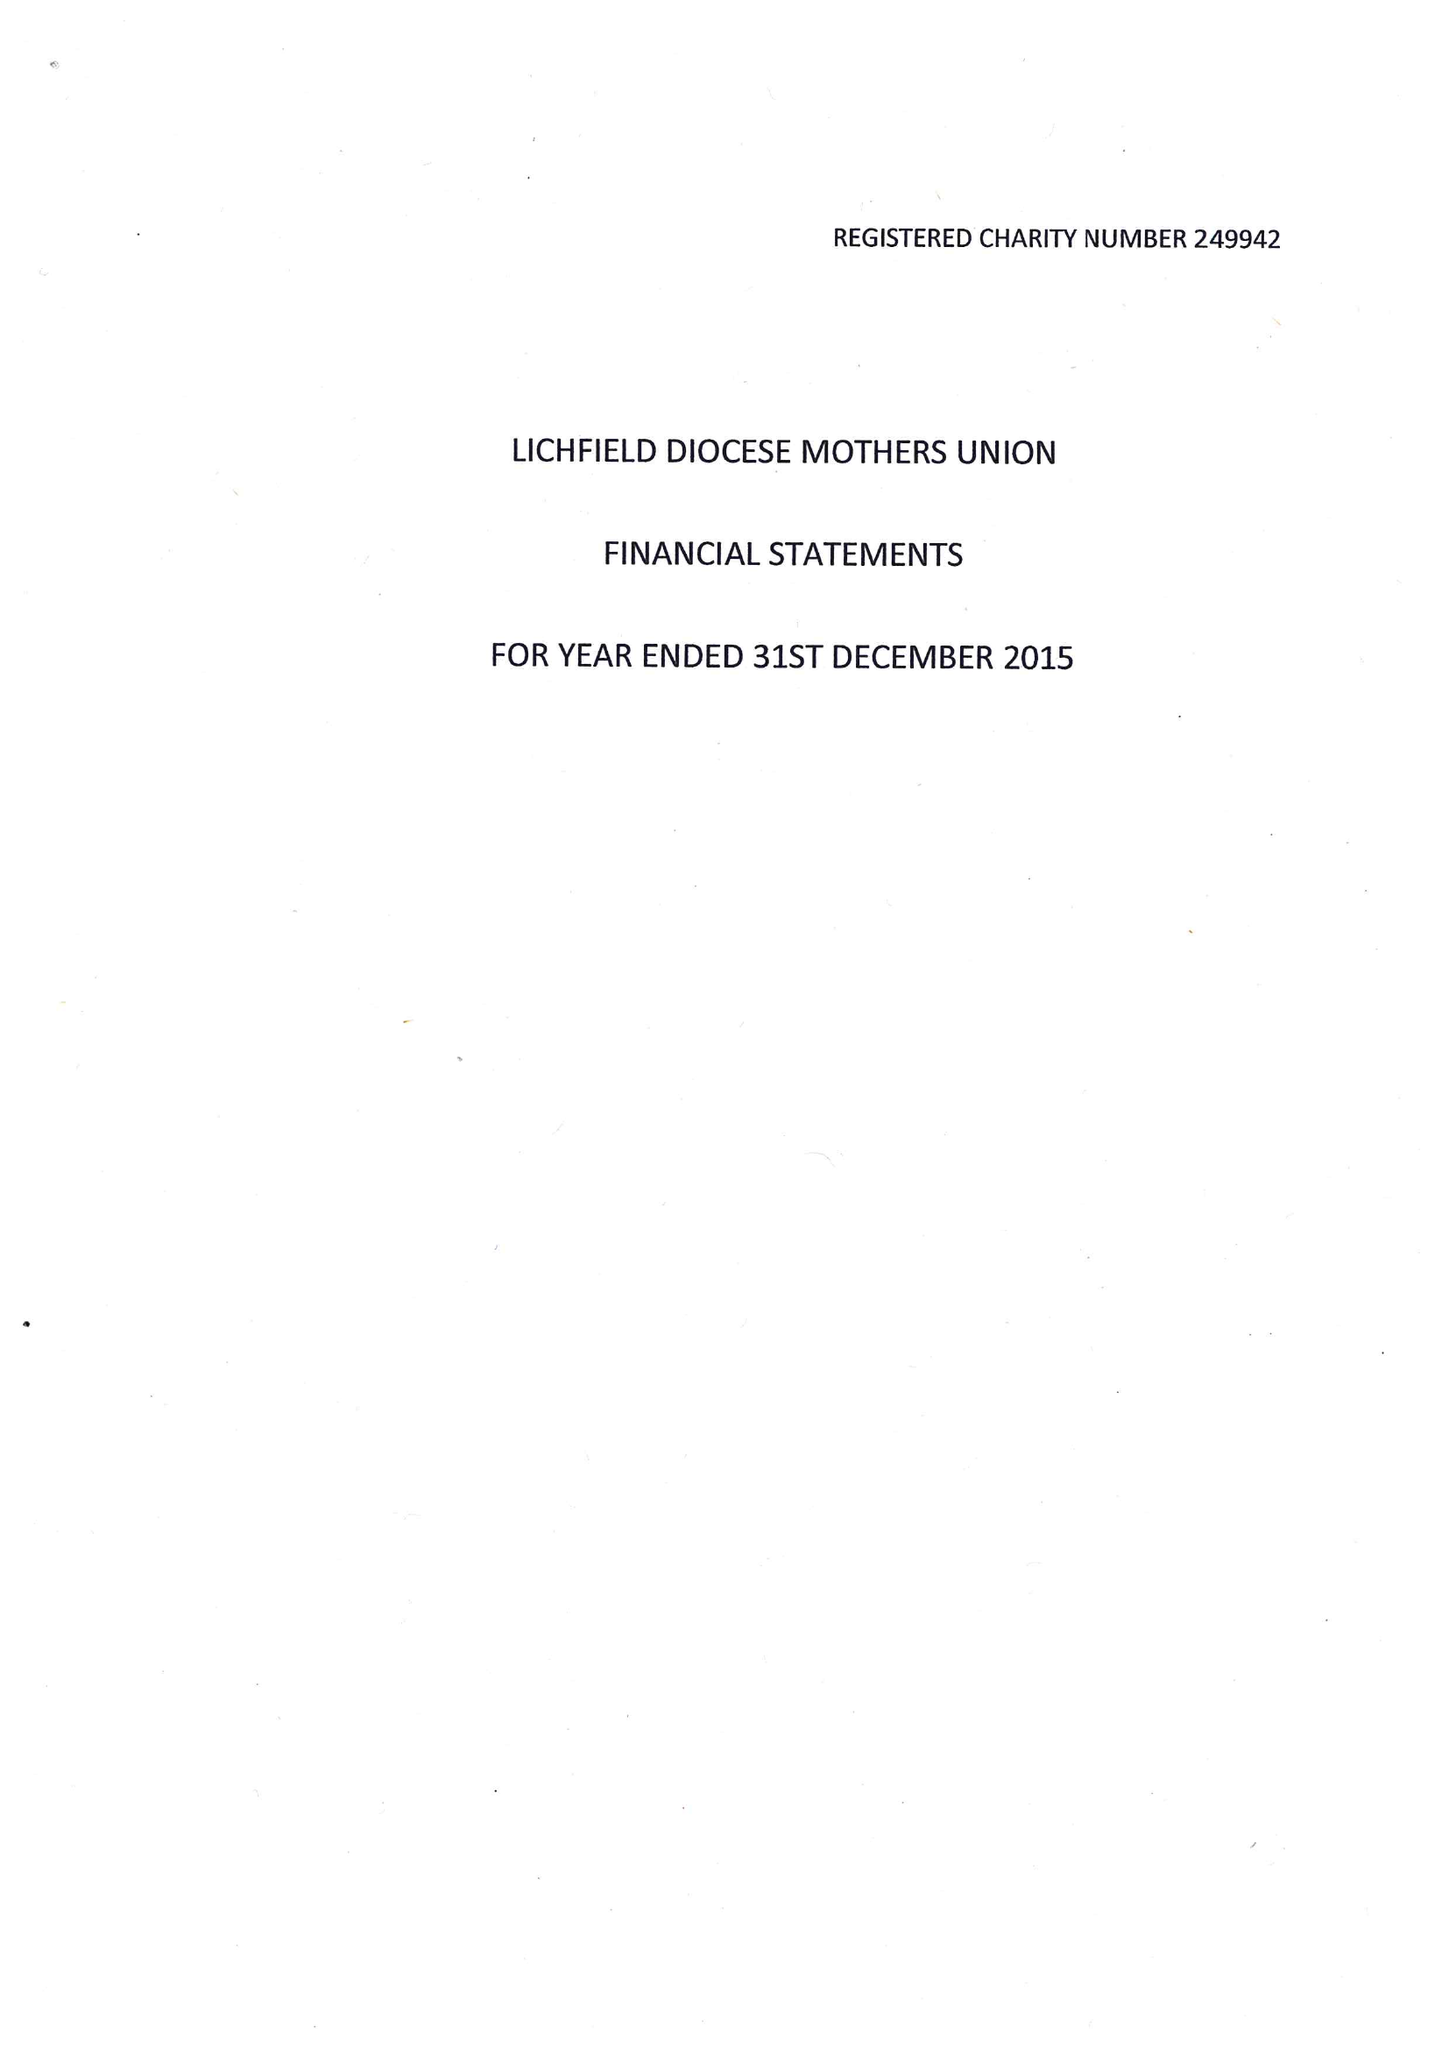What is the value for the income_annually_in_british_pounds?
Answer the question using a single word or phrase. 96482.00 